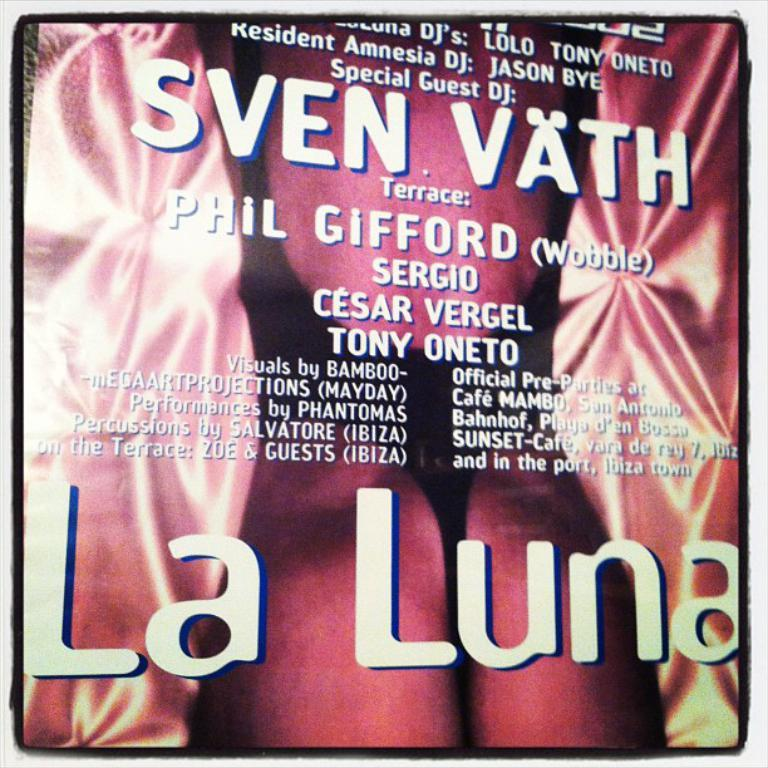<image>
Share a concise interpretation of the image provided. an advertisement for the music festival featuring special guest dj sven vath. 